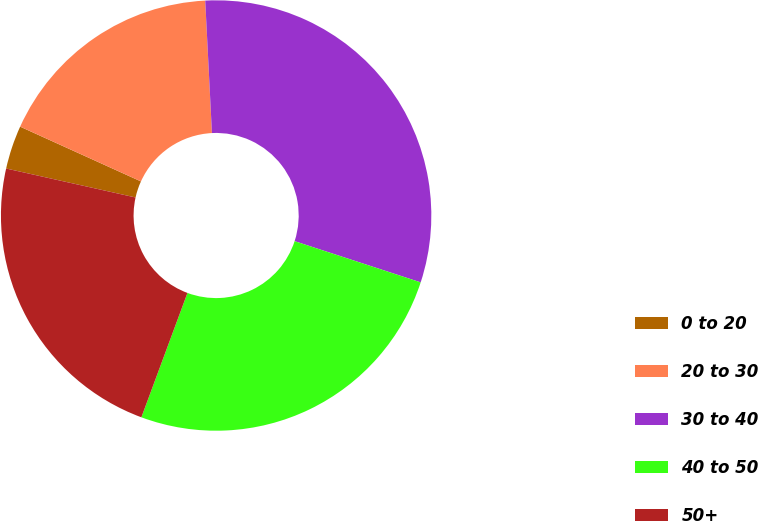Convert chart to OTSL. <chart><loc_0><loc_0><loc_500><loc_500><pie_chart><fcel>0 to 20<fcel>20 to 30<fcel>30 to 40<fcel>40 to 50<fcel>50+<nl><fcel>3.27%<fcel>17.42%<fcel>30.84%<fcel>25.62%<fcel>22.86%<nl></chart> 